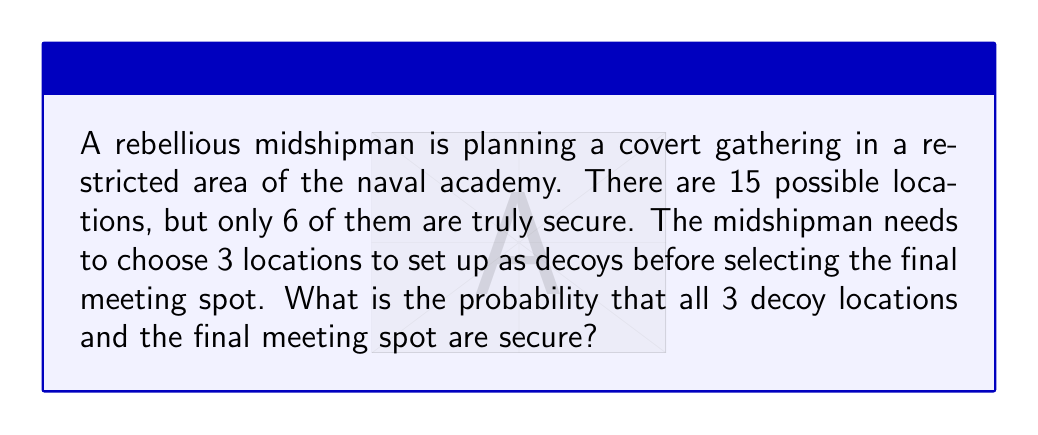What is the answer to this math problem? Let's approach this step-by-step:

1) First, we need to choose 3 decoy locations from the 6 secure locations. This can be done in $\binom{6}{3}$ ways.

2) After setting up the decoys, we need to choose 1 more secure location from the remaining 3 for the actual meeting. This can be done in $\binom{3}{1}$ ways.

3) The total number of favorable outcomes is therefore:

   $$\binom{6}{3} \cdot \binom{3}{1}$$

4) Now, for the total number of possible outcomes, we're choosing 4 locations (3 decoys + 1 meeting spot) from 15 total locations. This can be done in $\binom{15}{4}$ ways.

5) The probability is the number of favorable outcomes divided by the total number of possible outcomes:

   $$P(\text{all secure}) = \frac{\binom{6}{3} \cdot \binom{3}{1}}{\binom{15}{4}}$$

6) Let's calculate each part:
   
   $\binom{6}{3} = \frac{6!}{3!(6-3)!} = \frac{6 \cdot 5 \cdot 4}{3 \cdot 2 \cdot 1} = 20$
   
   $\binom{3}{1} = 3$
   
   $\binom{15}{4} = \frac{15!}{4!(15-4)!} = \frac{15 \cdot 14 \cdot 13 \cdot 12}{4 \cdot 3 \cdot 2 \cdot 1} = 1365$

7) Substituting these values:

   $$P(\text{all secure}) = \frac{20 \cdot 3}{1365} = \frac{60}{1365} = \frac{4}{91} \approx 0.044$$
Answer: The probability that all 3 decoy locations and the final meeting spot are secure is $\frac{4}{91}$ or approximately 0.044 (4.4%). 